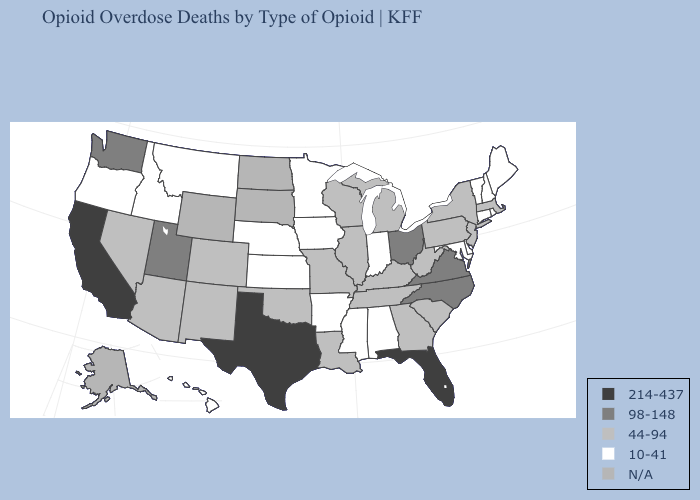What is the value of Maine?
Concise answer only. 10-41. What is the highest value in the Northeast ?
Write a very short answer. 44-94. Which states hav the highest value in the South?
Short answer required. Florida, Texas. What is the highest value in the South ?
Be succinct. 214-437. What is the value of Oregon?
Quick response, please. 10-41. What is the lowest value in the USA?
Keep it brief. 10-41. What is the value of Colorado?
Keep it brief. 44-94. How many symbols are there in the legend?
Give a very brief answer. 5. Among the states that border Utah , does Nevada have the highest value?
Keep it brief. Yes. What is the highest value in the USA?
Be succinct. 214-437. Name the states that have a value in the range 98-148?
Quick response, please. North Carolina, Ohio, Utah, Virginia, Washington. Among the states that border Pennsylvania , which have the lowest value?
Answer briefly. Delaware, Maryland. Which states have the highest value in the USA?
Keep it brief. California, Florida, Texas. Name the states that have a value in the range 44-94?
Short answer required. Arizona, Colorado, Georgia, Illinois, Kentucky, Louisiana, Massachusetts, Michigan, Missouri, Nevada, New Jersey, New Mexico, New York, Oklahoma, Pennsylvania, South Carolina, Tennessee, West Virginia, Wisconsin. 